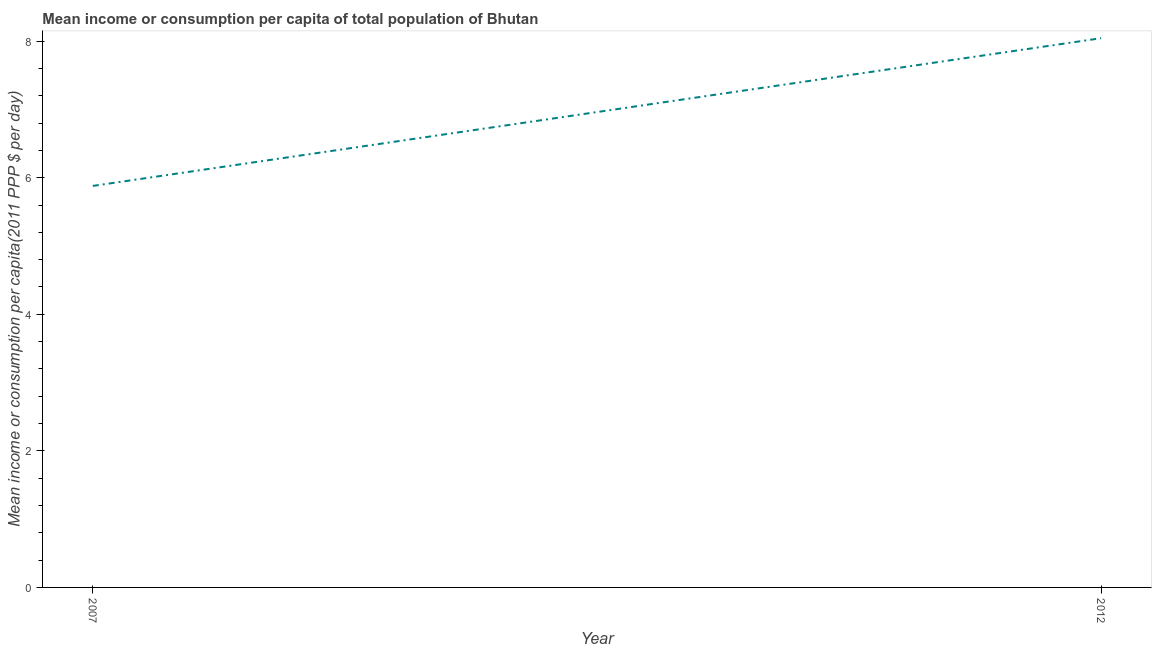What is the mean income or consumption in 2012?
Make the answer very short. 8.04. Across all years, what is the maximum mean income or consumption?
Offer a terse response. 8.04. Across all years, what is the minimum mean income or consumption?
Provide a short and direct response. 5.88. What is the sum of the mean income or consumption?
Offer a very short reply. 13.92. What is the difference between the mean income or consumption in 2007 and 2012?
Your response must be concise. -2.16. What is the average mean income or consumption per year?
Provide a succinct answer. 6.96. What is the median mean income or consumption?
Your answer should be very brief. 6.96. In how many years, is the mean income or consumption greater than 2.4 $?
Provide a succinct answer. 2. What is the ratio of the mean income or consumption in 2007 to that in 2012?
Your answer should be compact. 0.73. Is the mean income or consumption in 2007 less than that in 2012?
Keep it short and to the point. Yes. In how many years, is the mean income or consumption greater than the average mean income or consumption taken over all years?
Provide a succinct answer. 1. Are the values on the major ticks of Y-axis written in scientific E-notation?
Your response must be concise. No. What is the title of the graph?
Provide a succinct answer. Mean income or consumption per capita of total population of Bhutan. What is the label or title of the X-axis?
Give a very brief answer. Year. What is the label or title of the Y-axis?
Provide a succinct answer. Mean income or consumption per capita(2011 PPP $ per day). What is the Mean income or consumption per capita(2011 PPP $ per day) in 2007?
Offer a very short reply. 5.88. What is the Mean income or consumption per capita(2011 PPP $ per day) in 2012?
Keep it short and to the point. 8.04. What is the difference between the Mean income or consumption per capita(2011 PPP $ per day) in 2007 and 2012?
Keep it short and to the point. -2.16. What is the ratio of the Mean income or consumption per capita(2011 PPP $ per day) in 2007 to that in 2012?
Offer a terse response. 0.73. 